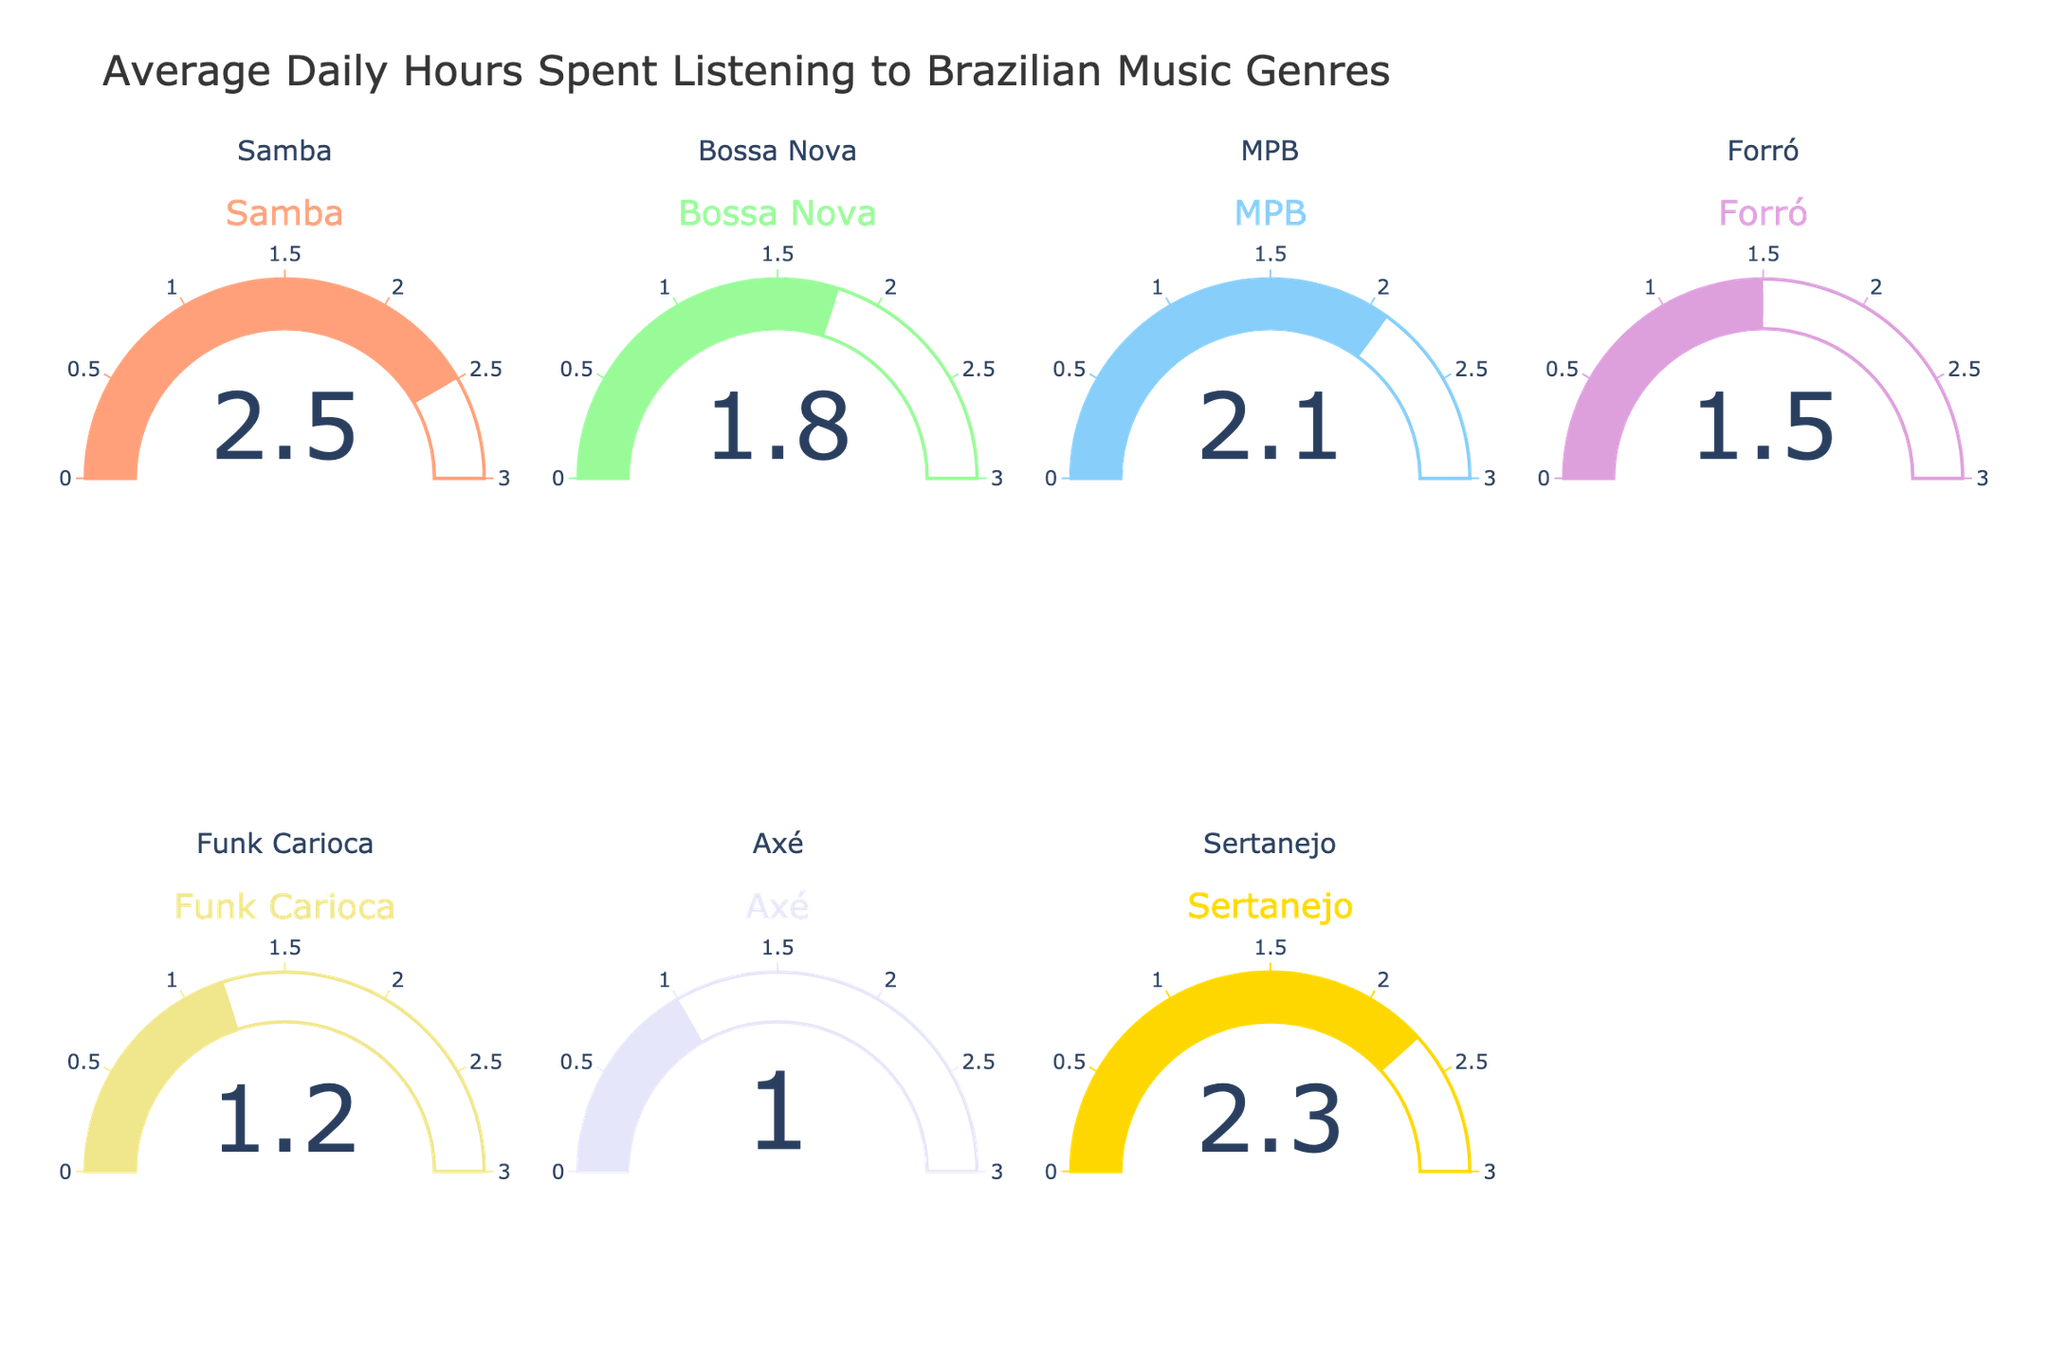Which genre has the highest average daily hours spent listening? By observing the gauge charts, the genre with the highest value will be the one with the largest number on its gauge. Samba has the highest value at 2.5 hours.
Answer: Samba What is the total average daily hours spent listening to all genres? Sum all the values from each gauge: 2.5 (Samba) + 1.8 (Bossa Nova) + 2.1 (MPB) + 1.5 (Forró) + 1.2 (Funk Carioca) + 1.0 (Axé) + 2.3 (Sertanejo) = 12.4 hours.
Answer: 12.4 How much more time is spent listening to Samba than Funk Carioca daily on average? Subtract the value of Funk Carioca from the value of Samba: 2.5 - 1.2 = 1.3 hours.
Answer: 1.3 Which genres have an average daily listening time greater than 2 hours? Identify genres with values greater than 2 from the gauges. Samba (2.5), MPB (2.1), and Sertanejo (2.3) meet this criterion.
Answer: Samba, MPB, Sertanejo If we consider only MPB and Sertanejo, what is their average listening time? Average the values of MPB and Sertanejo: (2.1 + 2.3) / 2 = 2.2 hours.
Answer: 2.2 Rank the genres from highest to lowest average listening hours. List the genres in descending order of their values: Samba (2.5), Sertanejo (2.3), MPB (2.1), Bossa Nova (1.8), Forró (1.5), Funk Carioca (1.2), Axé (1.0).
Answer: Samba, Sertanejo, MPB, Bossa Nova, Forró, Funk Carioca, Axé Which genre has the lowest average daily hours spent listening? By locating the lowest value on the gauges, Axé has the smallest number at 1.0 hours.
Answer: Axé Calculate the difference in average daily listening times between Bossa Nova and MPB. Subtract the value of Bossa Nova from MPB: 2.1 - 1.8 = 0.3 hours.
Answer: 0.3 What is the combined average daily listening time for Bossa Nova, MPB, and Sertanejo? Sum the values of Bossa Nova, MPB, and Sertanejo: 1.8 + 2.1 + 2.3 = 6.2 hours.
Answer: 6.2 